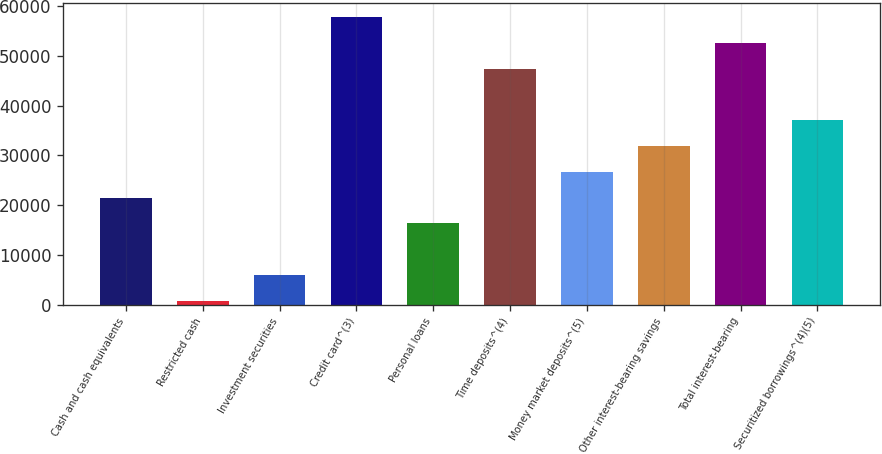<chart> <loc_0><loc_0><loc_500><loc_500><bar_chart><fcel>Cash and cash equivalents<fcel>Restricted cash<fcel>Investment securities<fcel>Credit card^(3)<fcel>Personal loans<fcel>Time deposits^(4)<fcel>Money market deposits^(5)<fcel>Other interest-bearing savings<fcel>Total interest-bearing<fcel>Securitized borrowings^(4)(5)<nl><fcel>21497.8<fcel>763<fcel>5946.7<fcel>57783.7<fcel>16314.1<fcel>47416.3<fcel>26681.5<fcel>31865.2<fcel>52600<fcel>37048.9<nl></chart> 